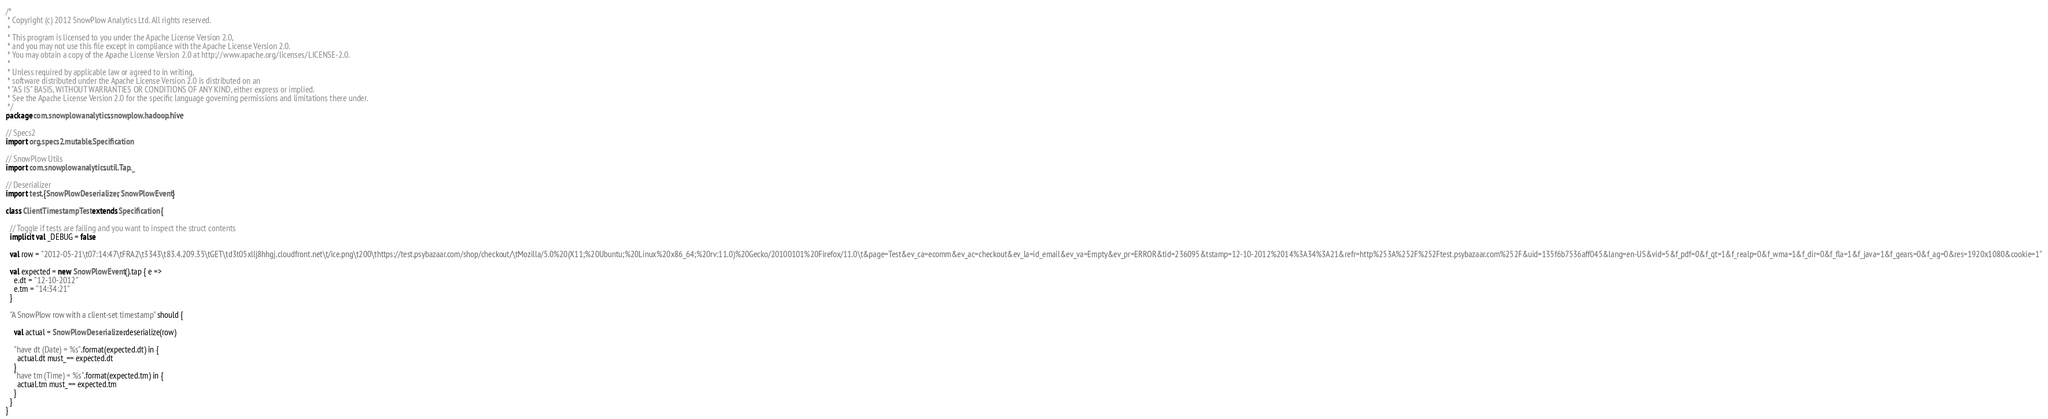<code> <loc_0><loc_0><loc_500><loc_500><_Scala_>/*
 * Copyright (c) 2012 SnowPlow Analytics Ltd. All rights reserved.
 *
 * This program is licensed to you under the Apache License Version 2.0,
 * and you may not use this file except in compliance with the Apache License Version 2.0.
 * You may obtain a copy of the Apache License Version 2.0 at http://www.apache.org/licenses/LICENSE-2.0.
 *
 * Unless required by applicable law or agreed to in writing,
 * software distributed under the Apache License Version 2.0 is distributed on an
 * "AS IS" BASIS, WITHOUT WARRANTIES OR CONDITIONS OF ANY KIND, either express or implied.
 * See the Apache License Version 2.0 for the specific language governing permissions and limitations there under.
 */
package com.snowplowanalytics.snowplow.hadoop.hive

// Specs2
import org.specs2.mutable.Specification

// SnowPlow Utils
import com.snowplowanalytics.util.Tap._

// Deserializer
import test.{SnowPlowDeserializer, SnowPlowEvent}

class ClientTimestampTest extends Specification {

  // Toggle if tests are failing and you want to inspect the struct contents
  implicit val _DEBUG = false

  val row = "2012-05-21\t07:14:47\tFRA2\t3343\t83.4.209.35\tGET\td3t05xllj8hhgj.cloudfront.net\t/ice.png\t200\thttps://test.psybazaar.com/shop/checkout/\tMozilla/5.0%20(X11;%20Ubuntu;%20Linux%20x86_64;%20rv:11.0)%20Gecko/20100101%20Firefox/11.0\t&page=Test&ev_ca=ecomm&ev_ac=checkout&ev_la=id_email&ev_va=Empty&ev_pr=ERROR&tid=236095&tstamp=12-10-2012%2014%3A34%3A21&refr=http%253A%252F%252Ftest.psybazaar.com%252F&uid=135f6b7536aff045&lang=en-US&vid=5&f_pdf=0&f_qt=1&f_realp=0&f_wma=1&f_dir=0&f_fla=1&f_java=1&f_gears=0&f_ag=0&res=1920x1080&cookie=1"
  
  val expected = new SnowPlowEvent().tap { e =>
    e.dt = "12-10-2012"
    e.tm = "14:34:21"
  }
  
  "A SnowPlow row with a client-set timestamp" should {

    val actual = SnowPlowDeserializer.deserialize(row)

    "have dt (Date) = %s".format(expected.dt) in {
      actual.dt must_== expected.dt
    }
    "have tm (Time) = %s".format(expected.tm) in {
      actual.tm must_== expected.tm
    }
  }
}
</code> 